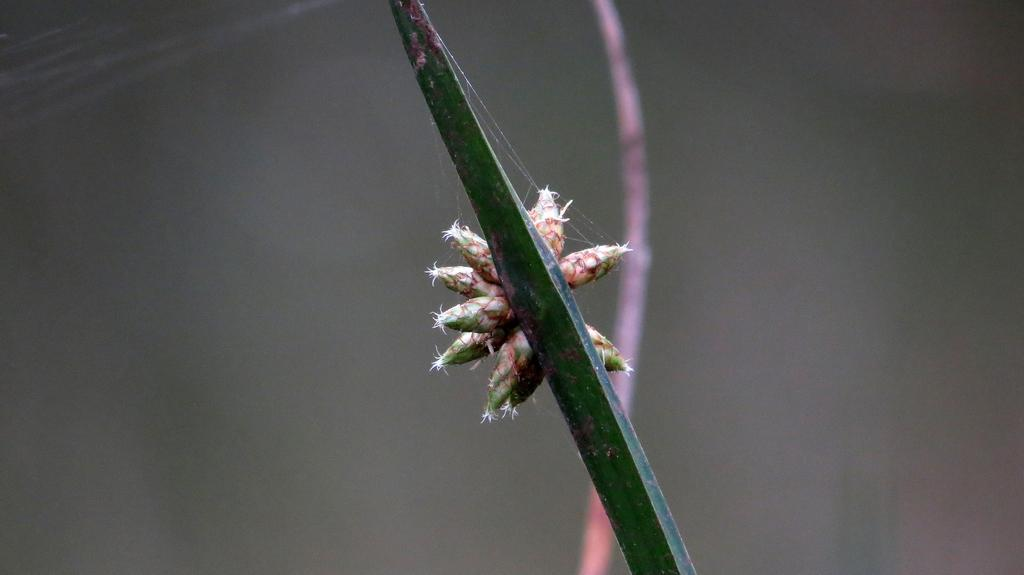Where was the image taken? The image was taken outdoors. What is the color of the background in the image? The background of the image is gray in color. What is the main subject of the image? The main subject of the image is a stem of a plant. Can you describe the plant stem in the image? Yes, there is a stem of a plant in the middle of the image, and there are a few buds on the plant stem. What degree of temperature is required for the plant to grow in the image? There is no information provided about the temperature or growing conditions of the plant in the image. Is there any evidence of war or conflict in the image? No, there is no evidence of war or conflict in the image; it features a plant stem with buds. 